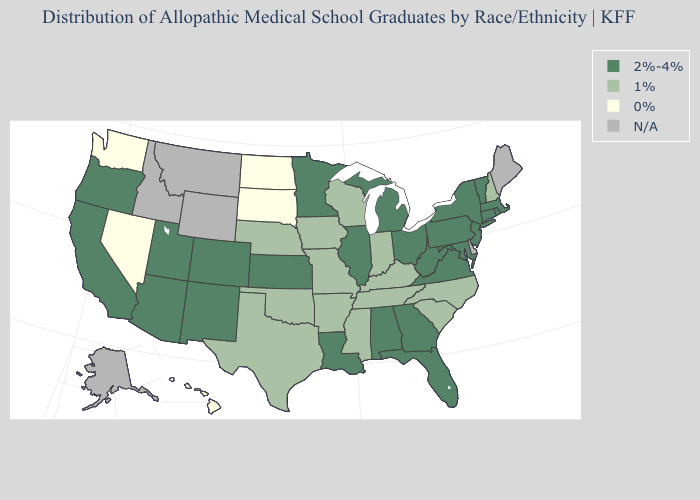Name the states that have a value in the range 0%?
Concise answer only. Hawaii, Nevada, North Dakota, South Dakota, Washington. Name the states that have a value in the range N/A?
Be succinct. Alaska, Delaware, Idaho, Maine, Montana, Wyoming. Name the states that have a value in the range 1%?
Be succinct. Arkansas, Indiana, Iowa, Kentucky, Mississippi, Missouri, Nebraska, New Hampshire, North Carolina, Oklahoma, South Carolina, Tennessee, Texas, Wisconsin. Does the first symbol in the legend represent the smallest category?
Answer briefly. No. What is the value of Arkansas?
Concise answer only. 1%. Which states have the lowest value in the MidWest?
Concise answer only. North Dakota, South Dakota. Name the states that have a value in the range 2%-4%?
Be succinct. Alabama, Arizona, California, Colorado, Connecticut, Florida, Georgia, Illinois, Kansas, Louisiana, Maryland, Massachusetts, Michigan, Minnesota, New Jersey, New Mexico, New York, Ohio, Oregon, Pennsylvania, Rhode Island, Utah, Vermont, Virginia, West Virginia. Which states have the highest value in the USA?
Write a very short answer. Alabama, Arizona, California, Colorado, Connecticut, Florida, Georgia, Illinois, Kansas, Louisiana, Maryland, Massachusetts, Michigan, Minnesota, New Jersey, New Mexico, New York, Ohio, Oregon, Pennsylvania, Rhode Island, Utah, Vermont, Virginia, West Virginia. What is the lowest value in the South?
Short answer required. 1%. What is the lowest value in the USA?
Quick response, please. 0%. What is the lowest value in states that border Indiana?
Be succinct. 1%. Which states have the lowest value in the USA?
Write a very short answer. Hawaii, Nevada, North Dakota, South Dakota, Washington. What is the value of Montana?
Short answer required. N/A. Does the first symbol in the legend represent the smallest category?
Concise answer only. No. 